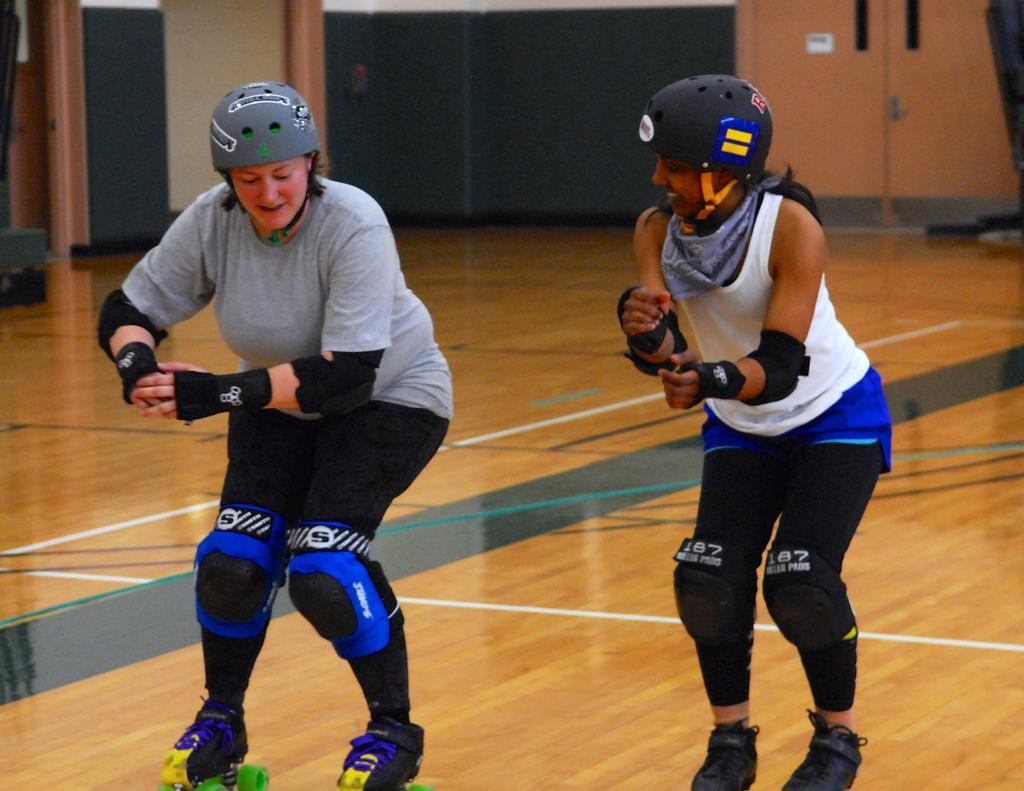In one or two sentences, can you explain what this image depicts? In this image in the center there are two people they are wearing helmets, and it seems that one person is skating. At the bottom there is floor, and in the background there are doors, pillars, wall and some objects. 